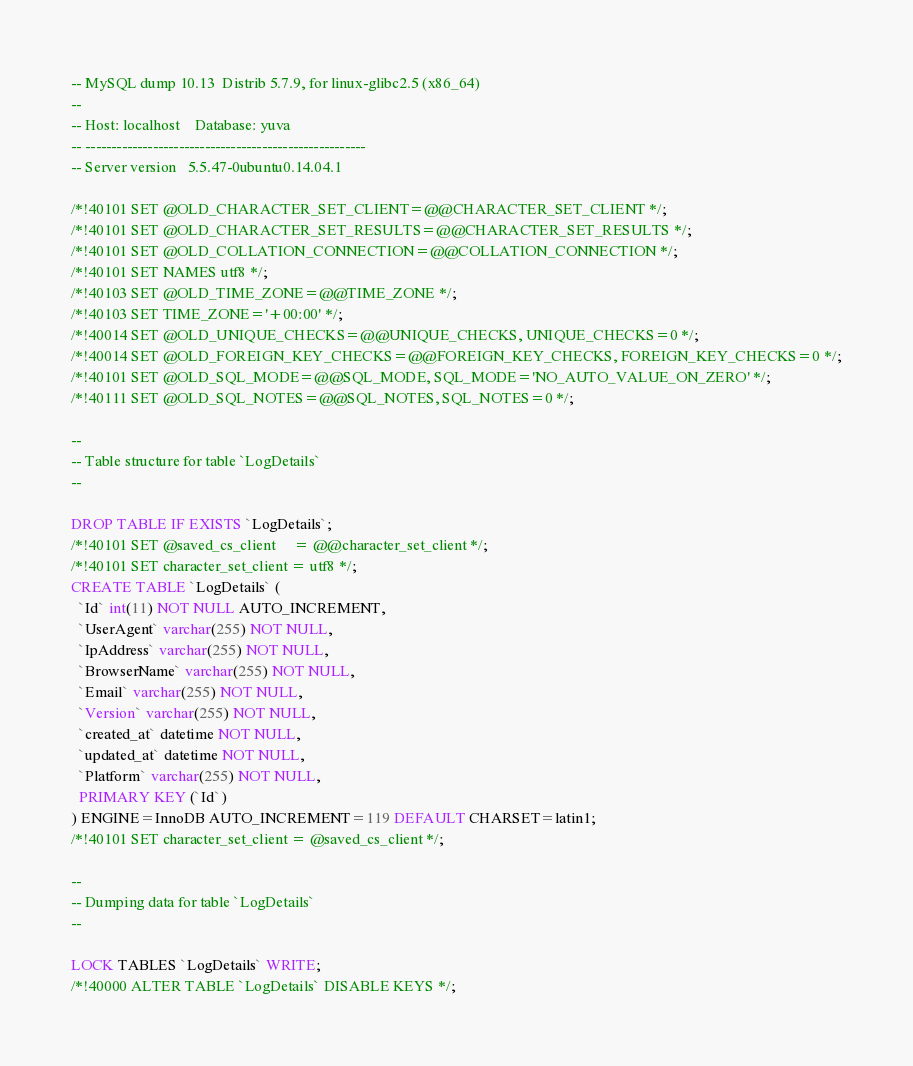<code> <loc_0><loc_0><loc_500><loc_500><_SQL_>-- MySQL dump 10.13  Distrib 5.7.9, for linux-glibc2.5 (x86_64)
--
-- Host: localhost    Database: yuva
-- ------------------------------------------------------
-- Server version	5.5.47-0ubuntu0.14.04.1

/*!40101 SET @OLD_CHARACTER_SET_CLIENT=@@CHARACTER_SET_CLIENT */;
/*!40101 SET @OLD_CHARACTER_SET_RESULTS=@@CHARACTER_SET_RESULTS */;
/*!40101 SET @OLD_COLLATION_CONNECTION=@@COLLATION_CONNECTION */;
/*!40101 SET NAMES utf8 */;
/*!40103 SET @OLD_TIME_ZONE=@@TIME_ZONE */;
/*!40103 SET TIME_ZONE='+00:00' */;
/*!40014 SET @OLD_UNIQUE_CHECKS=@@UNIQUE_CHECKS, UNIQUE_CHECKS=0 */;
/*!40014 SET @OLD_FOREIGN_KEY_CHECKS=@@FOREIGN_KEY_CHECKS, FOREIGN_KEY_CHECKS=0 */;
/*!40101 SET @OLD_SQL_MODE=@@SQL_MODE, SQL_MODE='NO_AUTO_VALUE_ON_ZERO' */;
/*!40111 SET @OLD_SQL_NOTES=@@SQL_NOTES, SQL_NOTES=0 */;

--
-- Table structure for table `LogDetails`
--

DROP TABLE IF EXISTS `LogDetails`;
/*!40101 SET @saved_cs_client     = @@character_set_client */;
/*!40101 SET character_set_client = utf8 */;
CREATE TABLE `LogDetails` (
  `Id` int(11) NOT NULL AUTO_INCREMENT,
  `UserAgent` varchar(255) NOT NULL,
  `IpAddress` varchar(255) NOT NULL,
  `BrowserName` varchar(255) NOT NULL,
  `Email` varchar(255) NOT NULL,
  `Version` varchar(255) NOT NULL,
  `created_at` datetime NOT NULL,
  `updated_at` datetime NOT NULL,
  `Platform` varchar(255) NOT NULL,
  PRIMARY KEY (`Id`)
) ENGINE=InnoDB AUTO_INCREMENT=119 DEFAULT CHARSET=latin1;
/*!40101 SET character_set_client = @saved_cs_client */;

--
-- Dumping data for table `LogDetails`
--

LOCK TABLES `LogDetails` WRITE;
/*!40000 ALTER TABLE `LogDetails` DISABLE KEYS */;</code> 